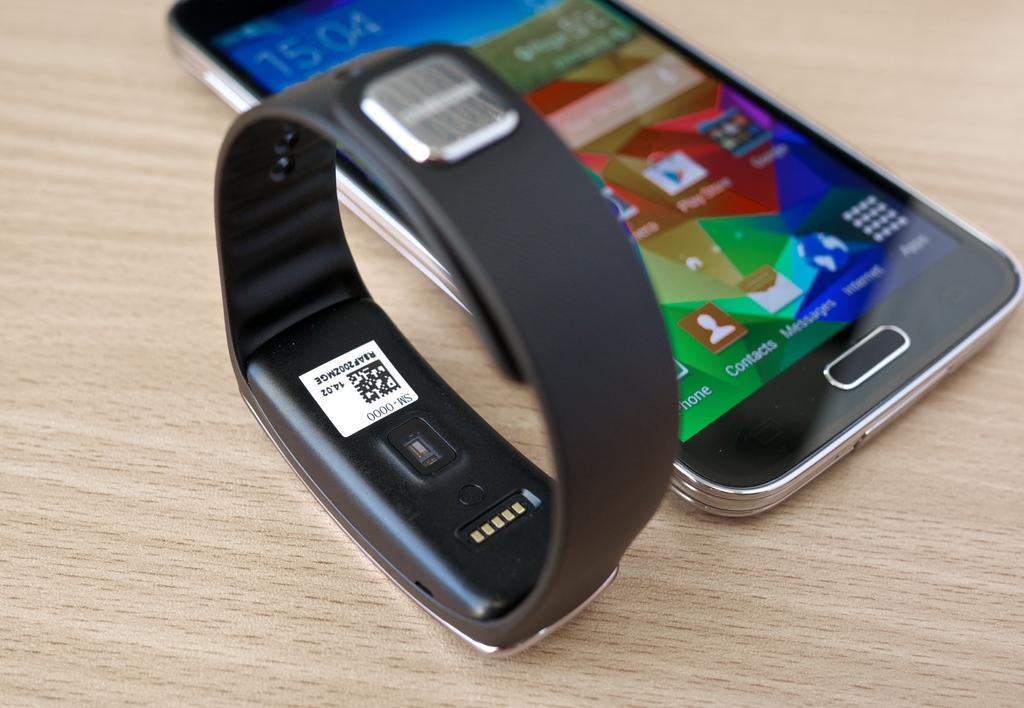What time is it on the phone?
Your answer should be compact. 15:04. 